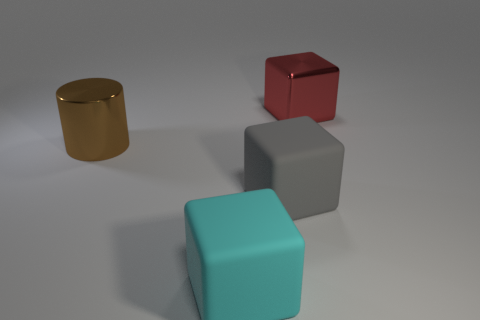Add 3 matte cubes. How many objects exist? 7 Subtract all cylinders. How many objects are left? 3 Subtract 0 purple blocks. How many objects are left? 4 Subtract all gray metallic cylinders. Subtract all big cyan things. How many objects are left? 3 Add 1 big gray things. How many big gray things are left? 2 Add 3 brown cylinders. How many brown cylinders exist? 4 